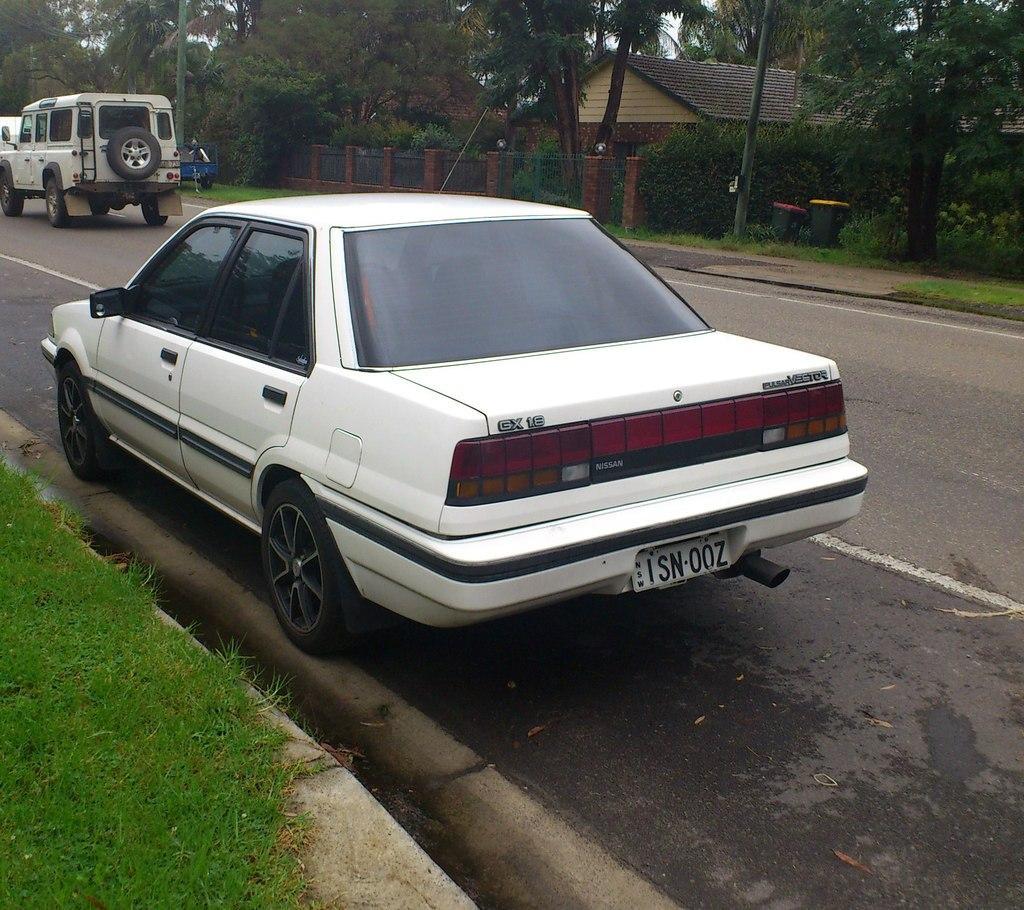How would you summarize this image in a sentence or two? In this image we can see group of vehicles parked on the road. In the background, we can see a fence ,building with roof, group of trees and trash bins. 